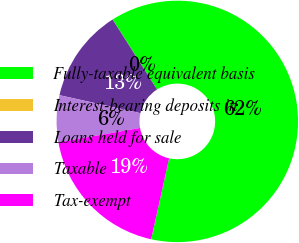<chart> <loc_0><loc_0><loc_500><loc_500><pie_chart><fcel>Fully-taxable equivalent basis<fcel>Interest-bearing deposits in<fcel>Loans held for sale<fcel>Taxable<fcel>Tax-exempt<nl><fcel>62.47%<fcel>0.01%<fcel>12.51%<fcel>6.26%<fcel>18.75%<nl></chart> 